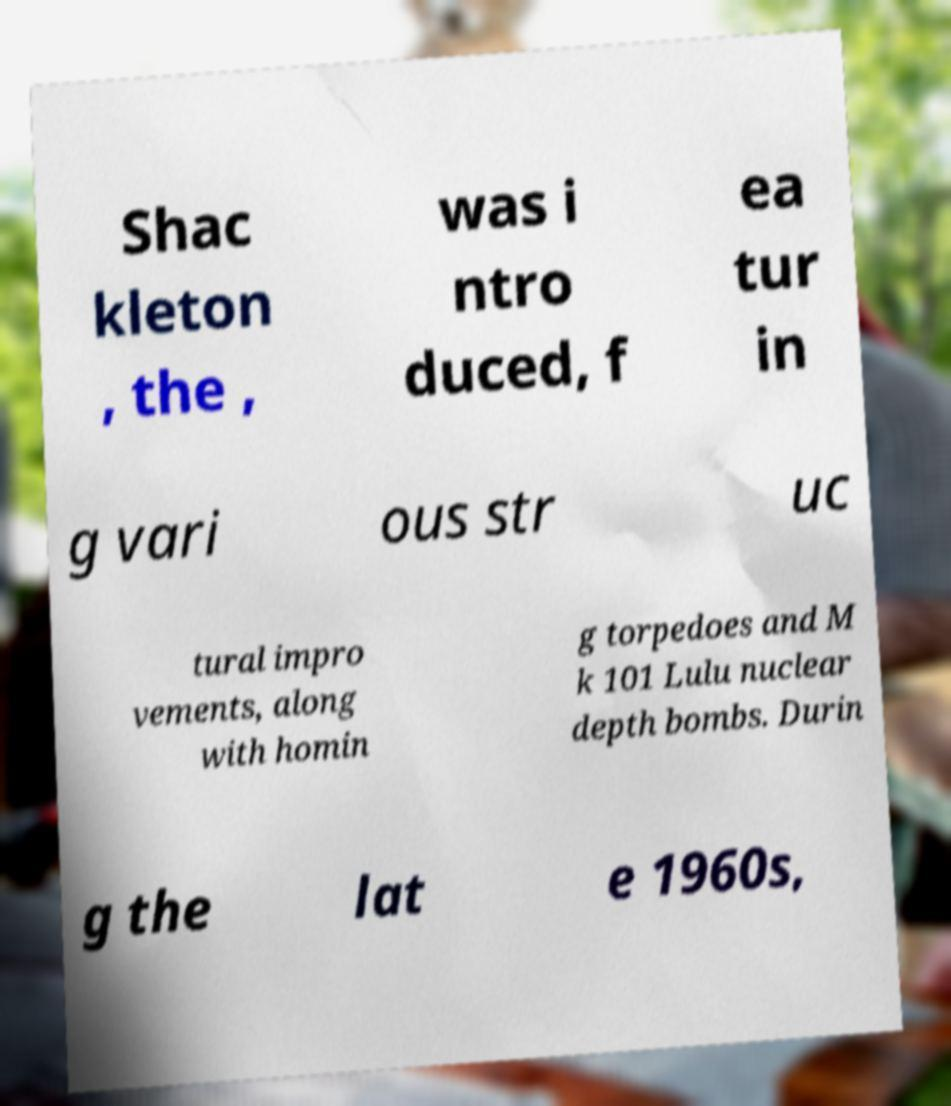For documentation purposes, I need the text within this image transcribed. Could you provide that? Shac kleton , the , was i ntro duced, f ea tur in g vari ous str uc tural impro vements, along with homin g torpedoes and M k 101 Lulu nuclear depth bombs. Durin g the lat e 1960s, 